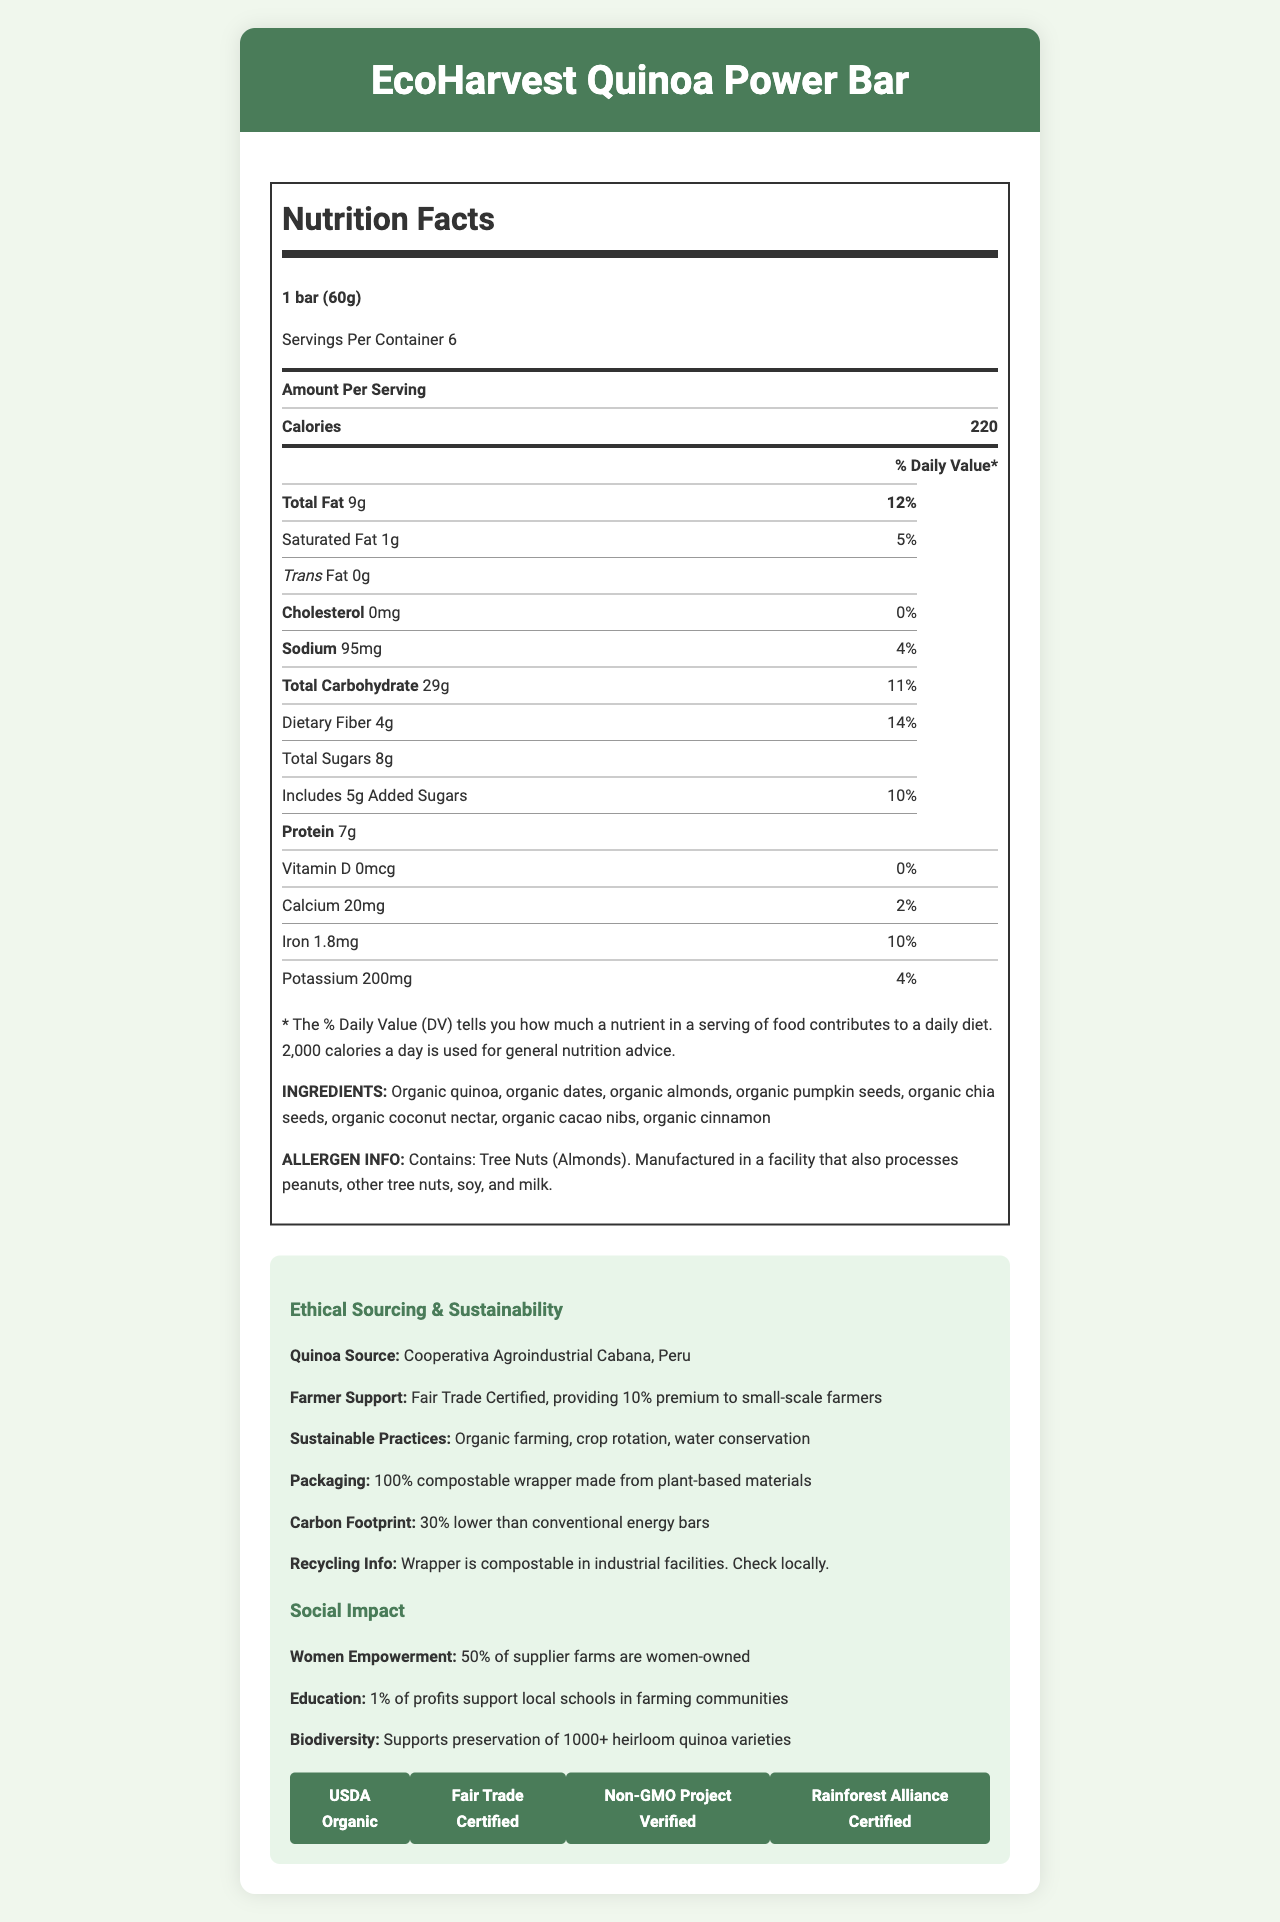What is the serving size of the EcoHarvest Quinoa Power Bar? The serving size is mentioned at the top of the document in the nutrition facts section as "1 bar (60g)".
Answer: 1 bar (60g) How many servings are there in a container of the EcoHarvest Quinoa Power Bar? The number of servings per container is provided under the serving size information, which is 6.
Answer: 6 What percentage of the daily value of dietary fiber does one serving of this energy bar provide? The document lists the dietary fiber content as 4g, which is 14% of the daily value.
Answer: 14% What are the total sugars in a serving of the EcoHarvest Quinoa Power Bar? The total sugars content is given as 8g in the nutritional information table.
Answer: 8g How much iron does one serving of this energy bar contain? The amount of iron in one serving is shown as 1.8mg, which is 10% of the daily value.
Answer: 1.8mg Which of the following certifications does the EcoHarvest Quinoa Power Bar have? A. USDA Organic B. Fair Trade Certified C. Non-GMO Project Verified D. All of the above The document lists certifications as USDA Organic, Fair Trade Certified, Non-GMO Project Verified, and Rainforest Alliance Certified, meaning option D is the correct answer.
Answer: D Where is the quinoa in the EcoHarvest Quinoa Power Bar sourced from? A. Bolivia B. Ecuador C. Peru The ethical sourcing section mentions that the quinoa is sourced from Cooperativa Agroindustrial Cabana in Peru.
Answer: C Does the EcoHarvest Quinoa Power Bar support women empowerment initiatives? The social impact section states that 50% of supplier farms are women-owned.
Answer: Yes Summarize the EcoHarvest Quinoa Power Bar's ethical and social impact practices. The document details ethical sourcing (Fair Trade Certified with a 10% premium to small-scale farmers, organic farming, and compostable packaging) and social impact initiatives (50% women-owned farms and supporting local schools).
Answer: The EcoHarvest Quinoa Power Bar supports small-scale farmers through Fair Trade practices, uses organic farming methods, has 100% compostable packaging, and promotes social initiatives like women empowerment and education. What is the percentage of added sugars in one serving in terms of daily value? The daily value percentage for added sugars is listed as 10% in the nutritional information section.
Answer: 10% Can the compostable wrapper of the EcoHarvest Quinoa Power Bar be composted at home? The document states that the wrapper is compostable in industrial facilities, but it does not specifically address home composting capabilities.
Answer: Not enough information How many calories are there in two bars of the EcoHarvest Quinoa Power Bar? One bar has 220 calories, so two bars would contain 220 x 2 = 440 calories.
Answer: 440 calories 